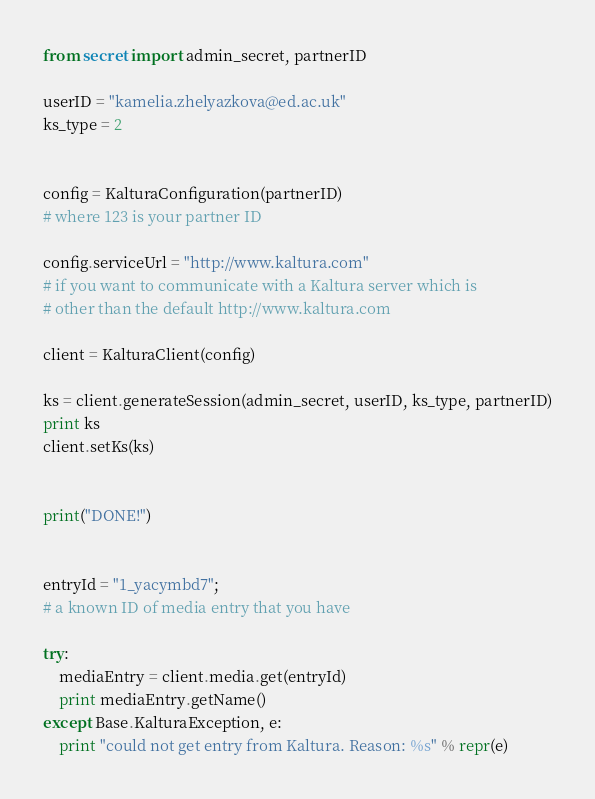Convert code to text. <code><loc_0><loc_0><loc_500><loc_500><_Python_>from secret import admin_secret, partnerID

userID = "kamelia.zhelyazkova@ed.ac.uk"
ks_type = 2


config = KalturaConfiguration(partnerID)
# where 123 is your partner ID

config.serviceUrl = "http://www.kaltura.com"
# if you want to communicate with a Kaltura server which is
# other than the default http://www.kaltura.com

client = KalturaClient(config)

ks = client.generateSession(admin_secret, userID, ks_type, partnerID)
print ks
client.setKs(ks)


print("DONE!")


entryId = "1_yacymbd7";
# a known ID of media entry that you have

try:
    mediaEntry = client.media.get(entryId)
    print mediaEntry.getName()
except Base.KalturaException, e:
    print "could not get entry from Kaltura. Reason: %s" % repr(e)

</code> 